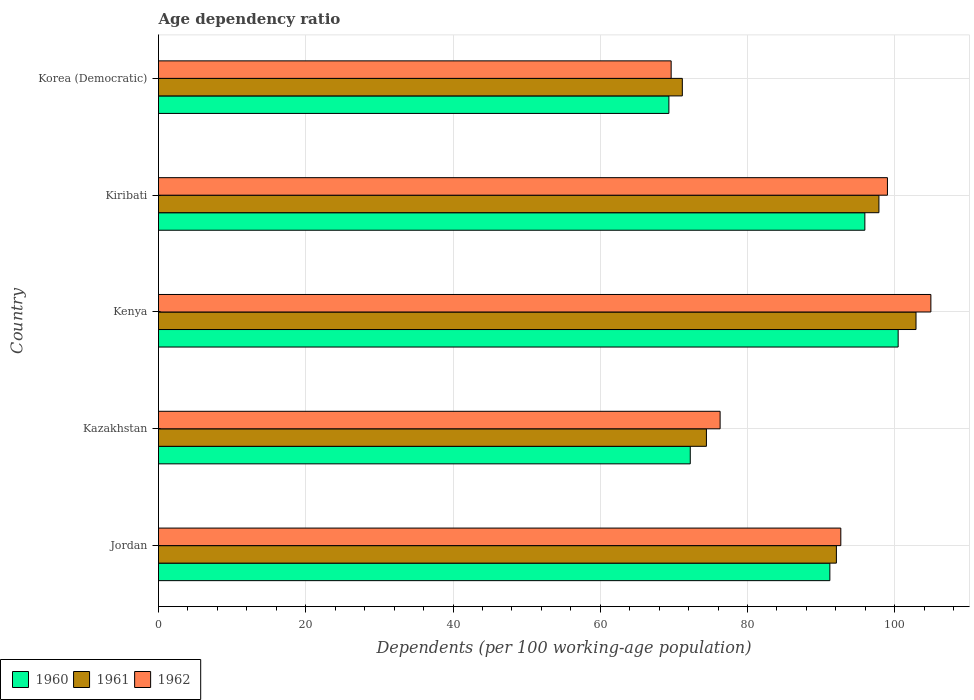How many groups of bars are there?
Keep it short and to the point. 5. Are the number of bars per tick equal to the number of legend labels?
Your response must be concise. Yes. Are the number of bars on each tick of the Y-axis equal?
Provide a succinct answer. Yes. What is the label of the 1st group of bars from the top?
Provide a short and direct response. Korea (Democratic). What is the age dependency ratio in in 1961 in Kenya?
Offer a terse response. 102.89. Across all countries, what is the maximum age dependency ratio in in 1962?
Your answer should be very brief. 104.91. Across all countries, what is the minimum age dependency ratio in in 1962?
Offer a very short reply. 69.63. In which country was the age dependency ratio in in 1961 maximum?
Keep it short and to the point. Kenya. In which country was the age dependency ratio in in 1961 minimum?
Your response must be concise. Korea (Democratic). What is the total age dependency ratio in in 1962 in the graph?
Keep it short and to the point. 442.5. What is the difference between the age dependency ratio in in 1960 in Kazakhstan and that in Kenya?
Your answer should be compact. -28.24. What is the difference between the age dependency ratio in in 1960 in Jordan and the age dependency ratio in in 1961 in Kenya?
Keep it short and to the point. -11.7. What is the average age dependency ratio in in 1960 per country?
Your response must be concise. 85.83. What is the difference between the age dependency ratio in in 1961 and age dependency ratio in in 1960 in Korea (Democratic)?
Give a very brief answer. 1.83. In how many countries, is the age dependency ratio in in 1960 greater than 40 %?
Provide a succinct answer. 5. What is the ratio of the age dependency ratio in in 1962 in Kazakhstan to that in Kiribati?
Keep it short and to the point. 0.77. Is the age dependency ratio in in 1962 in Kenya less than that in Korea (Democratic)?
Provide a short and direct response. No. Is the difference between the age dependency ratio in in 1961 in Jordan and Kiribati greater than the difference between the age dependency ratio in in 1960 in Jordan and Kiribati?
Offer a very short reply. No. What is the difference between the highest and the second highest age dependency ratio in in 1962?
Your answer should be compact. 5.9. What is the difference between the highest and the lowest age dependency ratio in in 1961?
Offer a very short reply. 31.74. In how many countries, is the age dependency ratio in in 1961 greater than the average age dependency ratio in in 1961 taken over all countries?
Give a very brief answer. 3. What does the 1st bar from the bottom in Kenya represents?
Ensure brevity in your answer.  1960. How many countries are there in the graph?
Your response must be concise. 5. Are the values on the major ticks of X-axis written in scientific E-notation?
Keep it short and to the point. No. Does the graph contain any zero values?
Make the answer very short. No. Does the graph contain grids?
Offer a terse response. Yes. Where does the legend appear in the graph?
Ensure brevity in your answer.  Bottom left. What is the title of the graph?
Make the answer very short. Age dependency ratio. What is the label or title of the X-axis?
Offer a terse response. Dependents (per 100 working-age population). What is the label or title of the Y-axis?
Your answer should be compact. Country. What is the Dependents (per 100 working-age population) of 1960 in Jordan?
Your answer should be compact. 91.19. What is the Dependents (per 100 working-age population) in 1961 in Jordan?
Make the answer very short. 92.07. What is the Dependents (per 100 working-age population) in 1962 in Jordan?
Make the answer very short. 92.68. What is the Dependents (per 100 working-age population) in 1960 in Kazakhstan?
Your answer should be compact. 72.23. What is the Dependents (per 100 working-age population) of 1961 in Kazakhstan?
Your response must be concise. 74.42. What is the Dependents (per 100 working-age population) in 1962 in Kazakhstan?
Offer a terse response. 76.28. What is the Dependents (per 100 working-age population) of 1960 in Kenya?
Ensure brevity in your answer.  100.46. What is the Dependents (per 100 working-age population) in 1961 in Kenya?
Your response must be concise. 102.89. What is the Dependents (per 100 working-age population) of 1962 in Kenya?
Your answer should be compact. 104.91. What is the Dependents (per 100 working-age population) of 1960 in Kiribati?
Ensure brevity in your answer.  95.94. What is the Dependents (per 100 working-age population) of 1961 in Kiribati?
Keep it short and to the point. 97.85. What is the Dependents (per 100 working-age population) in 1962 in Kiribati?
Your response must be concise. 99.01. What is the Dependents (per 100 working-age population) of 1960 in Korea (Democratic)?
Provide a short and direct response. 69.32. What is the Dependents (per 100 working-age population) in 1961 in Korea (Democratic)?
Offer a terse response. 71.15. What is the Dependents (per 100 working-age population) of 1962 in Korea (Democratic)?
Keep it short and to the point. 69.63. Across all countries, what is the maximum Dependents (per 100 working-age population) of 1960?
Your response must be concise. 100.46. Across all countries, what is the maximum Dependents (per 100 working-age population) of 1961?
Your answer should be very brief. 102.89. Across all countries, what is the maximum Dependents (per 100 working-age population) of 1962?
Provide a succinct answer. 104.91. Across all countries, what is the minimum Dependents (per 100 working-age population) in 1960?
Give a very brief answer. 69.32. Across all countries, what is the minimum Dependents (per 100 working-age population) of 1961?
Provide a short and direct response. 71.15. Across all countries, what is the minimum Dependents (per 100 working-age population) of 1962?
Give a very brief answer. 69.63. What is the total Dependents (per 100 working-age population) in 1960 in the graph?
Your answer should be very brief. 429.14. What is the total Dependents (per 100 working-age population) of 1961 in the graph?
Make the answer very short. 438.38. What is the total Dependents (per 100 working-age population) in 1962 in the graph?
Your answer should be compact. 442.5. What is the difference between the Dependents (per 100 working-age population) of 1960 in Jordan and that in Kazakhstan?
Keep it short and to the point. 18.96. What is the difference between the Dependents (per 100 working-age population) in 1961 in Jordan and that in Kazakhstan?
Make the answer very short. 17.65. What is the difference between the Dependents (per 100 working-age population) of 1962 in Jordan and that in Kazakhstan?
Your answer should be compact. 16.39. What is the difference between the Dependents (per 100 working-age population) of 1960 in Jordan and that in Kenya?
Offer a terse response. -9.28. What is the difference between the Dependents (per 100 working-age population) in 1961 in Jordan and that in Kenya?
Give a very brief answer. -10.82. What is the difference between the Dependents (per 100 working-age population) of 1962 in Jordan and that in Kenya?
Keep it short and to the point. -12.23. What is the difference between the Dependents (per 100 working-age population) in 1960 in Jordan and that in Kiribati?
Provide a succinct answer. -4.76. What is the difference between the Dependents (per 100 working-age population) of 1961 in Jordan and that in Kiribati?
Your answer should be compact. -5.78. What is the difference between the Dependents (per 100 working-age population) of 1962 in Jordan and that in Kiribati?
Keep it short and to the point. -6.33. What is the difference between the Dependents (per 100 working-age population) in 1960 in Jordan and that in Korea (Democratic)?
Provide a succinct answer. 21.86. What is the difference between the Dependents (per 100 working-age population) in 1961 in Jordan and that in Korea (Democratic)?
Give a very brief answer. 20.93. What is the difference between the Dependents (per 100 working-age population) in 1962 in Jordan and that in Korea (Democratic)?
Make the answer very short. 23.04. What is the difference between the Dependents (per 100 working-age population) of 1960 in Kazakhstan and that in Kenya?
Offer a very short reply. -28.24. What is the difference between the Dependents (per 100 working-age population) in 1961 in Kazakhstan and that in Kenya?
Offer a terse response. -28.47. What is the difference between the Dependents (per 100 working-age population) of 1962 in Kazakhstan and that in Kenya?
Provide a succinct answer. -28.63. What is the difference between the Dependents (per 100 working-age population) of 1960 in Kazakhstan and that in Kiribati?
Offer a very short reply. -23.71. What is the difference between the Dependents (per 100 working-age population) in 1961 in Kazakhstan and that in Kiribati?
Offer a terse response. -23.43. What is the difference between the Dependents (per 100 working-age population) of 1962 in Kazakhstan and that in Kiribati?
Give a very brief answer. -22.73. What is the difference between the Dependents (per 100 working-age population) of 1960 in Kazakhstan and that in Korea (Democratic)?
Offer a very short reply. 2.9. What is the difference between the Dependents (per 100 working-age population) of 1961 in Kazakhstan and that in Korea (Democratic)?
Offer a terse response. 3.27. What is the difference between the Dependents (per 100 working-age population) of 1962 in Kazakhstan and that in Korea (Democratic)?
Offer a terse response. 6.65. What is the difference between the Dependents (per 100 working-age population) of 1960 in Kenya and that in Kiribati?
Provide a short and direct response. 4.52. What is the difference between the Dependents (per 100 working-age population) in 1961 in Kenya and that in Kiribati?
Your answer should be compact. 5.04. What is the difference between the Dependents (per 100 working-age population) in 1962 in Kenya and that in Kiribati?
Provide a succinct answer. 5.9. What is the difference between the Dependents (per 100 working-age population) in 1960 in Kenya and that in Korea (Democratic)?
Keep it short and to the point. 31.14. What is the difference between the Dependents (per 100 working-age population) in 1961 in Kenya and that in Korea (Democratic)?
Offer a very short reply. 31.74. What is the difference between the Dependents (per 100 working-age population) in 1962 in Kenya and that in Korea (Democratic)?
Offer a terse response. 35.28. What is the difference between the Dependents (per 100 working-age population) of 1960 in Kiribati and that in Korea (Democratic)?
Offer a terse response. 26.62. What is the difference between the Dependents (per 100 working-age population) of 1961 in Kiribati and that in Korea (Democratic)?
Give a very brief answer. 26.7. What is the difference between the Dependents (per 100 working-age population) in 1962 in Kiribati and that in Korea (Democratic)?
Provide a short and direct response. 29.38. What is the difference between the Dependents (per 100 working-age population) in 1960 in Jordan and the Dependents (per 100 working-age population) in 1961 in Kazakhstan?
Keep it short and to the point. 16.77. What is the difference between the Dependents (per 100 working-age population) of 1960 in Jordan and the Dependents (per 100 working-age population) of 1962 in Kazakhstan?
Your response must be concise. 14.91. What is the difference between the Dependents (per 100 working-age population) in 1961 in Jordan and the Dependents (per 100 working-age population) in 1962 in Kazakhstan?
Give a very brief answer. 15.79. What is the difference between the Dependents (per 100 working-age population) in 1960 in Jordan and the Dependents (per 100 working-age population) in 1961 in Kenya?
Ensure brevity in your answer.  -11.7. What is the difference between the Dependents (per 100 working-age population) of 1960 in Jordan and the Dependents (per 100 working-age population) of 1962 in Kenya?
Your answer should be compact. -13.72. What is the difference between the Dependents (per 100 working-age population) in 1961 in Jordan and the Dependents (per 100 working-age population) in 1962 in Kenya?
Offer a very short reply. -12.83. What is the difference between the Dependents (per 100 working-age population) of 1960 in Jordan and the Dependents (per 100 working-age population) of 1961 in Kiribati?
Your answer should be compact. -6.66. What is the difference between the Dependents (per 100 working-age population) of 1960 in Jordan and the Dependents (per 100 working-age population) of 1962 in Kiribati?
Give a very brief answer. -7.82. What is the difference between the Dependents (per 100 working-age population) in 1961 in Jordan and the Dependents (per 100 working-age population) in 1962 in Kiribati?
Provide a succinct answer. -6.93. What is the difference between the Dependents (per 100 working-age population) of 1960 in Jordan and the Dependents (per 100 working-age population) of 1961 in Korea (Democratic)?
Make the answer very short. 20.04. What is the difference between the Dependents (per 100 working-age population) of 1960 in Jordan and the Dependents (per 100 working-age population) of 1962 in Korea (Democratic)?
Offer a terse response. 21.56. What is the difference between the Dependents (per 100 working-age population) of 1961 in Jordan and the Dependents (per 100 working-age population) of 1962 in Korea (Democratic)?
Ensure brevity in your answer.  22.44. What is the difference between the Dependents (per 100 working-age population) of 1960 in Kazakhstan and the Dependents (per 100 working-age population) of 1961 in Kenya?
Offer a very short reply. -30.66. What is the difference between the Dependents (per 100 working-age population) in 1960 in Kazakhstan and the Dependents (per 100 working-age population) in 1962 in Kenya?
Make the answer very short. -32.68. What is the difference between the Dependents (per 100 working-age population) of 1961 in Kazakhstan and the Dependents (per 100 working-age population) of 1962 in Kenya?
Keep it short and to the point. -30.49. What is the difference between the Dependents (per 100 working-age population) in 1960 in Kazakhstan and the Dependents (per 100 working-age population) in 1961 in Kiribati?
Offer a very short reply. -25.62. What is the difference between the Dependents (per 100 working-age population) of 1960 in Kazakhstan and the Dependents (per 100 working-age population) of 1962 in Kiribati?
Keep it short and to the point. -26.78. What is the difference between the Dependents (per 100 working-age population) of 1961 in Kazakhstan and the Dependents (per 100 working-age population) of 1962 in Kiribati?
Give a very brief answer. -24.59. What is the difference between the Dependents (per 100 working-age population) of 1960 in Kazakhstan and the Dependents (per 100 working-age population) of 1961 in Korea (Democratic)?
Ensure brevity in your answer.  1.08. What is the difference between the Dependents (per 100 working-age population) of 1960 in Kazakhstan and the Dependents (per 100 working-age population) of 1962 in Korea (Democratic)?
Provide a short and direct response. 2.6. What is the difference between the Dependents (per 100 working-age population) of 1961 in Kazakhstan and the Dependents (per 100 working-age population) of 1962 in Korea (Democratic)?
Ensure brevity in your answer.  4.79. What is the difference between the Dependents (per 100 working-age population) of 1960 in Kenya and the Dependents (per 100 working-age population) of 1961 in Kiribati?
Offer a terse response. 2.61. What is the difference between the Dependents (per 100 working-age population) in 1960 in Kenya and the Dependents (per 100 working-age population) in 1962 in Kiribati?
Your answer should be very brief. 1.46. What is the difference between the Dependents (per 100 working-age population) in 1961 in Kenya and the Dependents (per 100 working-age population) in 1962 in Kiribati?
Provide a short and direct response. 3.88. What is the difference between the Dependents (per 100 working-age population) in 1960 in Kenya and the Dependents (per 100 working-age population) in 1961 in Korea (Democratic)?
Ensure brevity in your answer.  29.32. What is the difference between the Dependents (per 100 working-age population) of 1960 in Kenya and the Dependents (per 100 working-age population) of 1962 in Korea (Democratic)?
Your answer should be compact. 30.83. What is the difference between the Dependents (per 100 working-age population) in 1961 in Kenya and the Dependents (per 100 working-age population) in 1962 in Korea (Democratic)?
Your response must be concise. 33.26. What is the difference between the Dependents (per 100 working-age population) in 1960 in Kiribati and the Dependents (per 100 working-age population) in 1961 in Korea (Democratic)?
Your answer should be very brief. 24.79. What is the difference between the Dependents (per 100 working-age population) of 1960 in Kiribati and the Dependents (per 100 working-age population) of 1962 in Korea (Democratic)?
Offer a very short reply. 26.31. What is the difference between the Dependents (per 100 working-age population) of 1961 in Kiribati and the Dependents (per 100 working-age population) of 1962 in Korea (Democratic)?
Give a very brief answer. 28.22. What is the average Dependents (per 100 working-age population) of 1960 per country?
Keep it short and to the point. 85.83. What is the average Dependents (per 100 working-age population) in 1961 per country?
Provide a short and direct response. 87.68. What is the average Dependents (per 100 working-age population) in 1962 per country?
Offer a terse response. 88.5. What is the difference between the Dependents (per 100 working-age population) of 1960 and Dependents (per 100 working-age population) of 1961 in Jordan?
Your response must be concise. -0.89. What is the difference between the Dependents (per 100 working-age population) of 1960 and Dependents (per 100 working-age population) of 1962 in Jordan?
Offer a very short reply. -1.49. What is the difference between the Dependents (per 100 working-age population) in 1961 and Dependents (per 100 working-age population) in 1962 in Jordan?
Give a very brief answer. -0.6. What is the difference between the Dependents (per 100 working-age population) of 1960 and Dependents (per 100 working-age population) of 1961 in Kazakhstan?
Your answer should be compact. -2.19. What is the difference between the Dependents (per 100 working-age population) in 1960 and Dependents (per 100 working-age population) in 1962 in Kazakhstan?
Provide a short and direct response. -4.05. What is the difference between the Dependents (per 100 working-age population) of 1961 and Dependents (per 100 working-age population) of 1962 in Kazakhstan?
Offer a terse response. -1.86. What is the difference between the Dependents (per 100 working-age population) in 1960 and Dependents (per 100 working-age population) in 1961 in Kenya?
Offer a terse response. -2.42. What is the difference between the Dependents (per 100 working-age population) in 1960 and Dependents (per 100 working-age population) in 1962 in Kenya?
Ensure brevity in your answer.  -4.44. What is the difference between the Dependents (per 100 working-age population) of 1961 and Dependents (per 100 working-age population) of 1962 in Kenya?
Provide a succinct answer. -2.02. What is the difference between the Dependents (per 100 working-age population) of 1960 and Dependents (per 100 working-age population) of 1961 in Kiribati?
Ensure brevity in your answer.  -1.91. What is the difference between the Dependents (per 100 working-age population) of 1960 and Dependents (per 100 working-age population) of 1962 in Kiribati?
Offer a very short reply. -3.07. What is the difference between the Dependents (per 100 working-age population) of 1961 and Dependents (per 100 working-age population) of 1962 in Kiribati?
Make the answer very short. -1.16. What is the difference between the Dependents (per 100 working-age population) of 1960 and Dependents (per 100 working-age population) of 1961 in Korea (Democratic)?
Your answer should be compact. -1.83. What is the difference between the Dependents (per 100 working-age population) of 1960 and Dependents (per 100 working-age population) of 1962 in Korea (Democratic)?
Make the answer very short. -0.31. What is the difference between the Dependents (per 100 working-age population) in 1961 and Dependents (per 100 working-age population) in 1962 in Korea (Democratic)?
Your answer should be compact. 1.52. What is the ratio of the Dependents (per 100 working-age population) in 1960 in Jordan to that in Kazakhstan?
Give a very brief answer. 1.26. What is the ratio of the Dependents (per 100 working-age population) of 1961 in Jordan to that in Kazakhstan?
Your response must be concise. 1.24. What is the ratio of the Dependents (per 100 working-age population) of 1962 in Jordan to that in Kazakhstan?
Offer a very short reply. 1.21. What is the ratio of the Dependents (per 100 working-age population) of 1960 in Jordan to that in Kenya?
Provide a succinct answer. 0.91. What is the ratio of the Dependents (per 100 working-age population) of 1961 in Jordan to that in Kenya?
Make the answer very short. 0.89. What is the ratio of the Dependents (per 100 working-age population) of 1962 in Jordan to that in Kenya?
Your response must be concise. 0.88. What is the ratio of the Dependents (per 100 working-age population) in 1960 in Jordan to that in Kiribati?
Provide a succinct answer. 0.95. What is the ratio of the Dependents (per 100 working-age population) in 1961 in Jordan to that in Kiribati?
Make the answer very short. 0.94. What is the ratio of the Dependents (per 100 working-age population) in 1962 in Jordan to that in Kiribati?
Make the answer very short. 0.94. What is the ratio of the Dependents (per 100 working-age population) of 1960 in Jordan to that in Korea (Democratic)?
Make the answer very short. 1.32. What is the ratio of the Dependents (per 100 working-age population) in 1961 in Jordan to that in Korea (Democratic)?
Make the answer very short. 1.29. What is the ratio of the Dependents (per 100 working-age population) of 1962 in Jordan to that in Korea (Democratic)?
Keep it short and to the point. 1.33. What is the ratio of the Dependents (per 100 working-age population) of 1960 in Kazakhstan to that in Kenya?
Give a very brief answer. 0.72. What is the ratio of the Dependents (per 100 working-age population) in 1961 in Kazakhstan to that in Kenya?
Ensure brevity in your answer.  0.72. What is the ratio of the Dependents (per 100 working-age population) of 1962 in Kazakhstan to that in Kenya?
Make the answer very short. 0.73. What is the ratio of the Dependents (per 100 working-age population) of 1960 in Kazakhstan to that in Kiribati?
Provide a succinct answer. 0.75. What is the ratio of the Dependents (per 100 working-age population) in 1961 in Kazakhstan to that in Kiribati?
Keep it short and to the point. 0.76. What is the ratio of the Dependents (per 100 working-age population) of 1962 in Kazakhstan to that in Kiribati?
Offer a very short reply. 0.77. What is the ratio of the Dependents (per 100 working-age population) of 1960 in Kazakhstan to that in Korea (Democratic)?
Provide a short and direct response. 1.04. What is the ratio of the Dependents (per 100 working-age population) of 1961 in Kazakhstan to that in Korea (Democratic)?
Ensure brevity in your answer.  1.05. What is the ratio of the Dependents (per 100 working-age population) in 1962 in Kazakhstan to that in Korea (Democratic)?
Provide a succinct answer. 1.1. What is the ratio of the Dependents (per 100 working-age population) of 1960 in Kenya to that in Kiribati?
Keep it short and to the point. 1.05. What is the ratio of the Dependents (per 100 working-age population) of 1961 in Kenya to that in Kiribati?
Provide a succinct answer. 1.05. What is the ratio of the Dependents (per 100 working-age population) in 1962 in Kenya to that in Kiribati?
Offer a very short reply. 1.06. What is the ratio of the Dependents (per 100 working-age population) in 1960 in Kenya to that in Korea (Democratic)?
Your response must be concise. 1.45. What is the ratio of the Dependents (per 100 working-age population) in 1961 in Kenya to that in Korea (Democratic)?
Provide a succinct answer. 1.45. What is the ratio of the Dependents (per 100 working-age population) in 1962 in Kenya to that in Korea (Democratic)?
Offer a terse response. 1.51. What is the ratio of the Dependents (per 100 working-age population) in 1960 in Kiribati to that in Korea (Democratic)?
Give a very brief answer. 1.38. What is the ratio of the Dependents (per 100 working-age population) in 1961 in Kiribati to that in Korea (Democratic)?
Ensure brevity in your answer.  1.38. What is the ratio of the Dependents (per 100 working-age population) in 1962 in Kiribati to that in Korea (Democratic)?
Your answer should be very brief. 1.42. What is the difference between the highest and the second highest Dependents (per 100 working-age population) of 1960?
Offer a very short reply. 4.52. What is the difference between the highest and the second highest Dependents (per 100 working-age population) in 1961?
Your answer should be compact. 5.04. What is the difference between the highest and the second highest Dependents (per 100 working-age population) in 1962?
Your answer should be compact. 5.9. What is the difference between the highest and the lowest Dependents (per 100 working-age population) of 1960?
Offer a very short reply. 31.14. What is the difference between the highest and the lowest Dependents (per 100 working-age population) in 1961?
Your answer should be compact. 31.74. What is the difference between the highest and the lowest Dependents (per 100 working-age population) in 1962?
Make the answer very short. 35.28. 